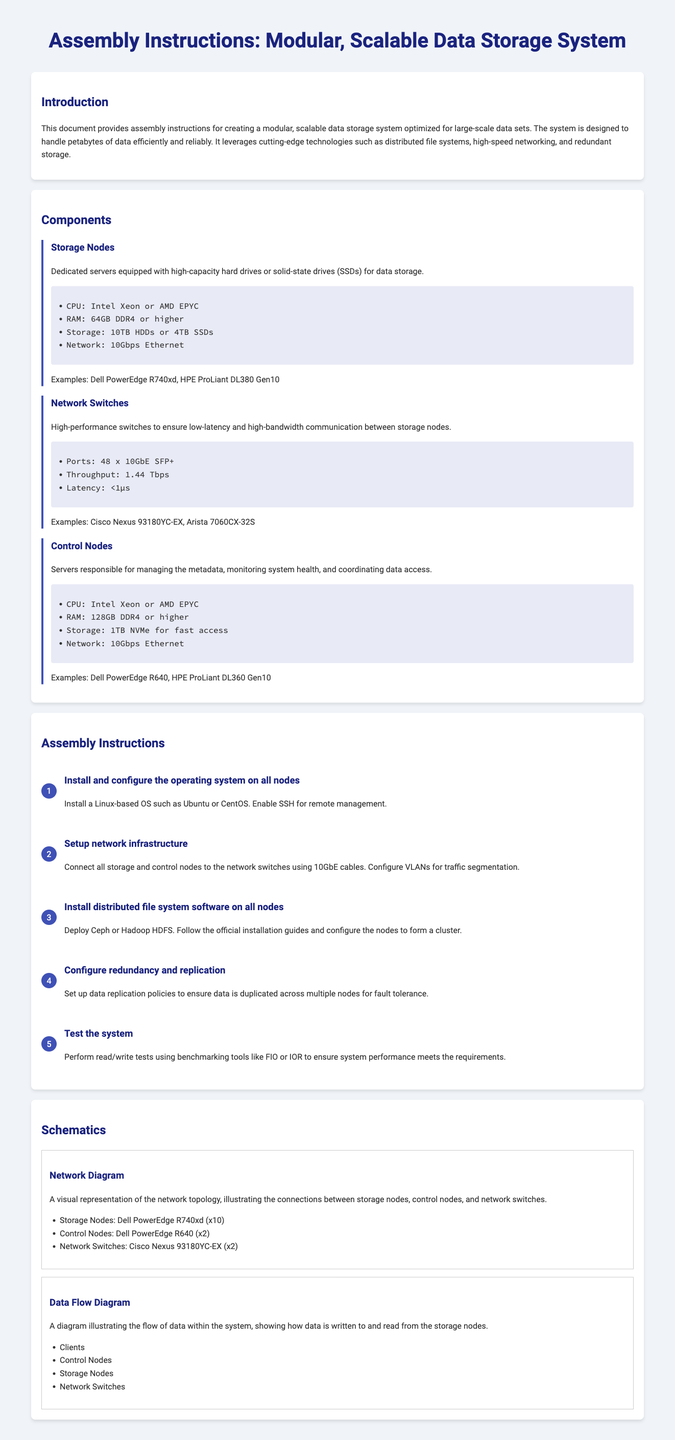What is the title of the document? The title of the document is presented in the header section, stating the purpose of the document clearly.
Answer: Assembly Instructions: Modular Data Storage System What is the recommended CPU for Storage Nodes? The specifications for Storage Nodes list the CPU options explicitly.
Answer: Intel Xeon or AMD EPYC How much RAM is required for Control Nodes? The specifications for Control Nodes detail the required RAM capacity.
Answer: 128GB DDR4 or higher What is the throughput of the Network Switches? The specifications for Network Switches include throughput information directly.
Answer: 1.44 Tbps What type of operating system should be installed? The assembly instructions specify the type of operating system recommended for installation.
Answer: Linux-based OS such as Ubuntu or CentOS How many Storage Nodes are suggested in the schematic? The network diagram in the schematics section indicates the number of Storage Nodes.
Answer: x10 What benchmarking tools are recommended for testing? The instructions for testing the system mention specific tools for benchmarking.
Answer: FIO or IOR What is the main purpose of the Control Nodes? The document outlines the responsibilities of the Control Nodes clearly.
Answer: Managing the metadata What is one example of a high-performance switch? Examples for Network Switches are provided in the document.
Answer: Cisco Nexus 93180YC-EX 